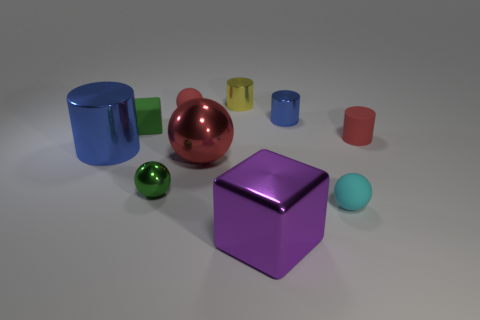Subtract 1 cylinders. How many cylinders are left? 3 Subtract all red cylinders. Subtract all green balls. How many cylinders are left? 3 Subtract all cubes. How many objects are left? 8 Subtract all large cyan shiny objects. Subtract all big blue cylinders. How many objects are left? 9 Add 2 green cubes. How many green cubes are left? 3 Add 9 gray shiny cubes. How many gray shiny cubes exist? 9 Subtract 0 brown balls. How many objects are left? 10 